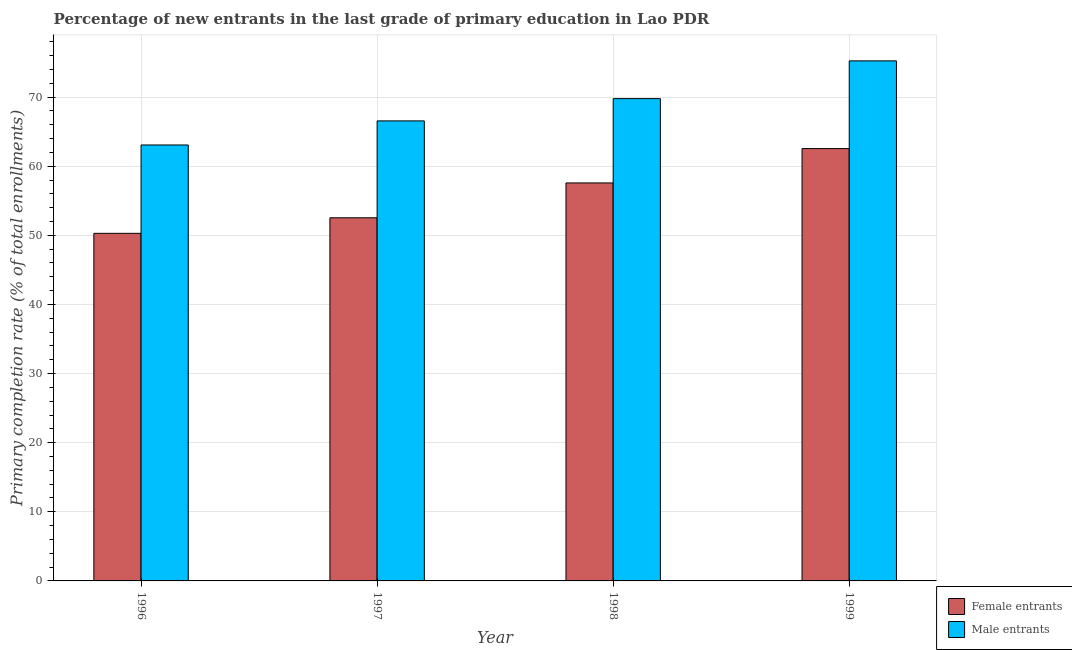How many groups of bars are there?
Your answer should be very brief. 4. Are the number of bars on each tick of the X-axis equal?
Make the answer very short. Yes. How many bars are there on the 3rd tick from the left?
Offer a very short reply. 2. What is the label of the 3rd group of bars from the left?
Your response must be concise. 1998. What is the primary completion rate of female entrants in 1999?
Offer a very short reply. 62.55. Across all years, what is the maximum primary completion rate of male entrants?
Provide a succinct answer. 75.24. Across all years, what is the minimum primary completion rate of female entrants?
Give a very brief answer. 50.29. In which year was the primary completion rate of female entrants maximum?
Offer a terse response. 1999. In which year was the primary completion rate of male entrants minimum?
Make the answer very short. 1996. What is the total primary completion rate of female entrants in the graph?
Make the answer very short. 222.95. What is the difference between the primary completion rate of female entrants in 1997 and that in 1999?
Give a very brief answer. -10.01. What is the difference between the primary completion rate of female entrants in 1997 and the primary completion rate of male entrants in 1998?
Your answer should be compact. -5.04. What is the average primary completion rate of male entrants per year?
Ensure brevity in your answer.  68.66. In the year 1997, what is the difference between the primary completion rate of female entrants and primary completion rate of male entrants?
Provide a succinct answer. 0. What is the ratio of the primary completion rate of female entrants in 1997 to that in 1999?
Provide a succinct answer. 0.84. What is the difference between the highest and the second highest primary completion rate of male entrants?
Your response must be concise. 5.46. What is the difference between the highest and the lowest primary completion rate of male entrants?
Your answer should be compact. 12.17. In how many years, is the primary completion rate of female entrants greater than the average primary completion rate of female entrants taken over all years?
Provide a short and direct response. 2. Is the sum of the primary completion rate of female entrants in 1996 and 1997 greater than the maximum primary completion rate of male entrants across all years?
Your response must be concise. Yes. What does the 2nd bar from the left in 1996 represents?
Your answer should be very brief. Male entrants. What does the 1st bar from the right in 1999 represents?
Make the answer very short. Male entrants. How many bars are there?
Your response must be concise. 8. Are all the bars in the graph horizontal?
Make the answer very short. No. Are the values on the major ticks of Y-axis written in scientific E-notation?
Provide a short and direct response. No. Does the graph contain any zero values?
Provide a short and direct response. No. Does the graph contain grids?
Your answer should be very brief. Yes. Where does the legend appear in the graph?
Offer a very short reply. Bottom right. What is the title of the graph?
Make the answer very short. Percentage of new entrants in the last grade of primary education in Lao PDR. Does "Fraud firms" appear as one of the legend labels in the graph?
Your response must be concise. No. What is the label or title of the X-axis?
Your response must be concise. Year. What is the label or title of the Y-axis?
Provide a short and direct response. Primary completion rate (% of total enrollments). What is the Primary completion rate (% of total enrollments) of Female entrants in 1996?
Keep it short and to the point. 50.29. What is the Primary completion rate (% of total enrollments) of Male entrants in 1996?
Offer a very short reply. 63.07. What is the Primary completion rate (% of total enrollments) in Female entrants in 1997?
Offer a very short reply. 52.54. What is the Primary completion rate (% of total enrollments) in Male entrants in 1997?
Make the answer very short. 66.55. What is the Primary completion rate (% of total enrollments) of Female entrants in 1998?
Your response must be concise. 57.58. What is the Primary completion rate (% of total enrollments) of Male entrants in 1998?
Offer a very short reply. 69.78. What is the Primary completion rate (% of total enrollments) in Female entrants in 1999?
Your answer should be very brief. 62.55. What is the Primary completion rate (% of total enrollments) in Male entrants in 1999?
Make the answer very short. 75.24. Across all years, what is the maximum Primary completion rate (% of total enrollments) in Female entrants?
Your answer should be compact. 62.55. Across all years, what is the maximum Primary completion rate (% of total enrollments) of Male entrants?
Keep it short and to the point. 75.24. Across all years, what is the minimum Primary completion rate (% of total enrollments) in Female entrants?
Offer a terse response. 50.29. Across all years, what is the minimum Primary completion rate (% of total enrollments) of Male entrants?
Your response must be concise. 63.07. What is the total Primary completion rate (% of total enrollments) in Female entrants in the graph?
Offer a terse response. 222.95. What is the total Primary completion rate (% of total enrollments) of Male entrants in the graph?
Keep it short and to the point. 274.64. What is the difference between the Primary completion rate (% of total enrollments) in Female entrants in 1996 and that in 1997?
Give a very brief answer. -2.25. What is the difference between the Primary completion rate (% of total enrollments) in Male entrants in 1996 and that in 1997?
Keep it short and to the point. -3.48. What is the difference between the Primary completion rate (% of total enrollments) of Female entrants in 1996 and that in 1998?
Ensure brevity in your answer.  -7.29. What is the difference between the Primary completion rate (% of total enrollments) in Male entrants in 1996 and that in 1998?
Your answer should be compact. -6.71. What is the difference between the Primary completion rate (% of total enrollments) of Female entrants in 1996 and that in 1999?
Ensure brevity in your answer.  -12.26. What is the difference between the Primary completion rate (% of total enrollments) of Male entrants in 1996 and that in 1999?
Offer a very short reply. -12.17. What is the difference between the Primary completion rate (% of total enrollments) of Female entrants in 1997 and that in 1998?
Offer a terse response. -5.04. What is the difference between the Primary completion rate (% of total enrollments) of Male entrants in 1997 and that in 1998?
Your answer should be compact. -3.22. What is the difference between the Primary completion rate (% of total enrollments) in Female entrants in 1997 and that in 1999?
Your answer should be very brief. -10.01. What is the difference between the Primary completion rate (% of total enrollments) of Male entrants in 1997 and that in 1999?
Offer a terse response. -8.68. What is the difference between the Primary completion rate (% of total enrollments) of Female entrants in 1998 and that in 1999?
Your answer should be compact. -4.97. What is the difference between the Primary completion rate (% of total enrollments) in Male entrants in 1998 and that in 1999?
Give a very brief answer. -5.46. What is the difference between the Primary completion rate (% of total enrollments) of Female entrants in 1996 and the Primary completion rate (% of total enrollments) of Male entrants in 1997?
Provide a short and direct response. -16.27. What is the difference between the Primary completion rate (% of total enrollments) of Female entrants in 1996 and the Primary completion rate (% of total enrollments) of Male entrants in 1998?
Your response must be concise. -19.49. What is the difference between the Primary completion rate (% of total enrollments) of Female entrants in 1996 and the Primary completion rate (% of total enrollments) of Male entrants in 1999?
Your response must be concise. -24.95. What is the difference between the Primary completion rate (% of total enrollments) in Female entrants in 1997 and the Primary completion rate (% of total enrollments) in Male entrants in 1998?
Your answer should be compact. -17.24. What is the difference between the Primary completion rate (% of total enrollments) of Female entrants in 1997 and the Primary completion rate (% of total enrollments) of Male entrants in 1999?
Keep it short and to the point. -22.7. What is the difference between the Primary completion rate (% of total enrollments) of Female entrants in 1998 and the Primary completion rate (% of total enrollments) of Male entrants in 1999?
Offer a very short reply. -17.66. What is the average Primary completion rate (% of total enrollments) of Female entrants per year?
Keep it short and to the point. 55.74. What is the average Primary completion rate (% of total enrollments) of Male entrants per year?
Your answer should be very brief. 68.66. In the year 1996, what is the difference between the Primary completion rate (% of total enrollments) of Female entrants and Primary completion rate (% of total enrollments) of Male entrants?
Provide a short and direct response. -12.78. In the year 1997, what is the difference between the Primary completion rate (% of total enrollments) of Female entrants and Primary completion rate (% of total enrollments) of Male entrants?
Give a very brief answer. -14.02. In the year 1998, what is the difference between the Primary completion rate (% of total enrollments) of Female entrants and Primary completion rate (% of total enrollments) of Male entrants?
Ensure brevity in your answer.  -12.2. In the year 1999, what is the difference between the Primary completion rate (% of total enrollments) in Female entrants and Primary completion rate (% of total enrollments) in Male entrants?
Make the answer very short. -12.69. What is the ratio of the Primary completion rate (% of total enrollments) of Female entrants in 1996 to that in 1997?
Offer a very short reply. 0.96. What is the ratio of the Primary completion rate (% of total enrollments) in Male entrants in 1996 to that in 1997?
Offer a terse response. 0.95. What is the ratio of the Primary completion rate (% of total enrollments) of Female entrants in 1996 to that in 1998?
Offer a terse response. 0.87. What is the ratio of the Primary completion rate (% of total enrollments) in Male entrants in 1996 to that in 1998?
Keep it short and to the point. 0.9. What is the ratio of the Primary completion rate (% of total enrollments) of Female entrants in 1996 to that in 1999?
Give a very brief answer. 0.8. What is the ratio of the Primary completion rate (% of total enrollments) in Male entrants in 1996 to that in 1999?
Give a very brief answer. 0.84. What is the ratio of the Primary completion rate (% of total enrollments) in Female entrants in 1997 to that in 1998?
Your answer should be compact. 0.91. What is the ratio of the Primary completion rate (% of total enrollments) in Male entrants in 1997 to that in 1998?
Keep it short and to the point. 0.95. What is the ratio of the Primary completion rate (% of total enrollments) of Female entrants in 1997 to that in 1999?
Give a very brief answer. 0.84. What is the ratio of the Primary completion rate (% of total enrollments) of Male entrants in 1997 to that in 1999?
Provide a succinct answer. 0.88. What is the ratio of the Primary completion rate (% of total enrollments) in Female entrants in 1998 to that in 1999?
Give a very brief answer. 0.92. What is the ratio of the Primary completion rate (% of total enrollments) in Male entrants in 1998 to that in 1999?
Offer a terse response. 0.93. What is the difference between the highest and the second highest Primary completion rate (% of total enrollments) of Female entrants?
Your response must be concise. 4.97. What is the difference between the highest and the second highest Primary completion rate (% of total enrollments) in Male entrants?
Keep it short and to the point. 5.46. What is the difference between the highest and the lowest Primary completion rate (% of total enrollments) of Female entrants?
Provide a short and direct response. 12.26. What is the difference between the highest and the lowest Primary completion rate (% of total enrollments) in Male entrants?
Keep it short and to the point. 12.17. 